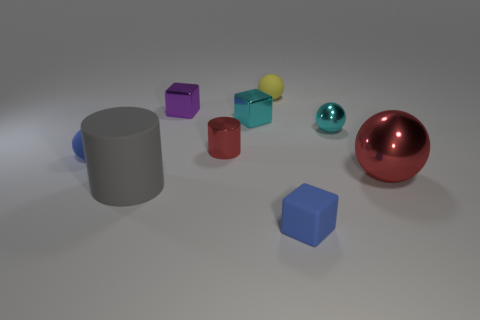Which object stands out the most to you, and why? The shiny red sphere stands out the most due to its reflective surface and the way it contrasts in color and shape with the surrounding objects, drawing the viewer's eye as a focal point. 